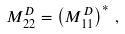<formula> <loc_0><loc_0><loc_500><loc_500>M _ { 2 2 } ^ { D } = \left ( M _ { 1 1 } ^ { D } \right ) ^ { \ast } \, ,</formula> 